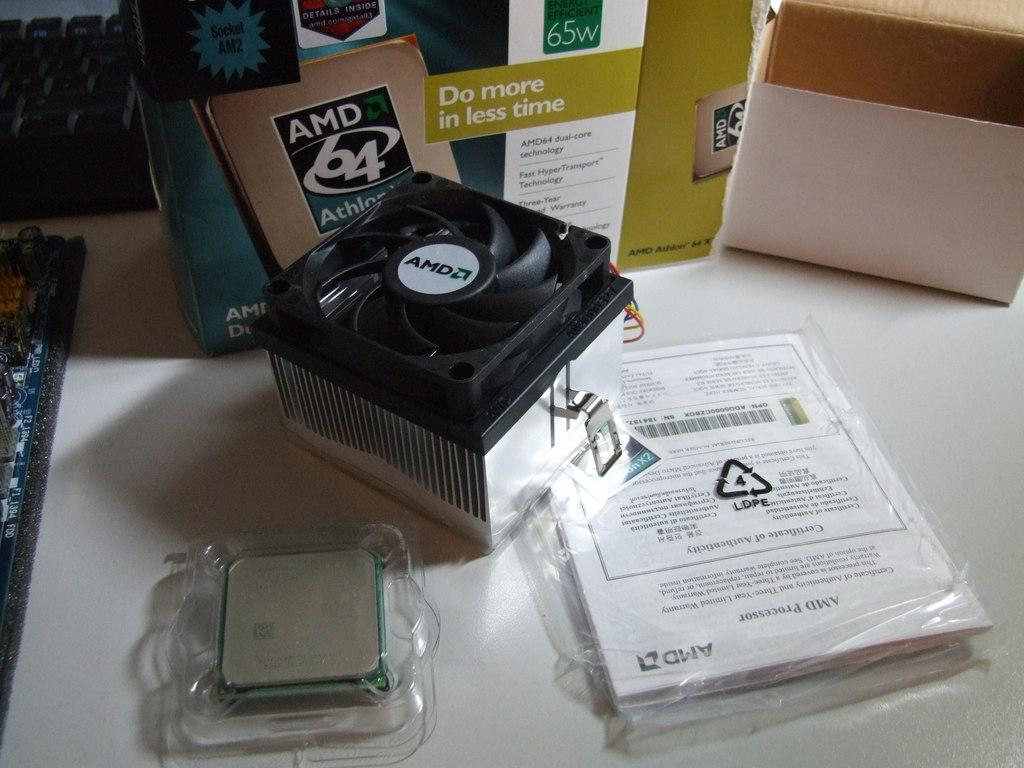Provide a one-sentence caption for the provided image. the phrase do more in less time is on a box. 